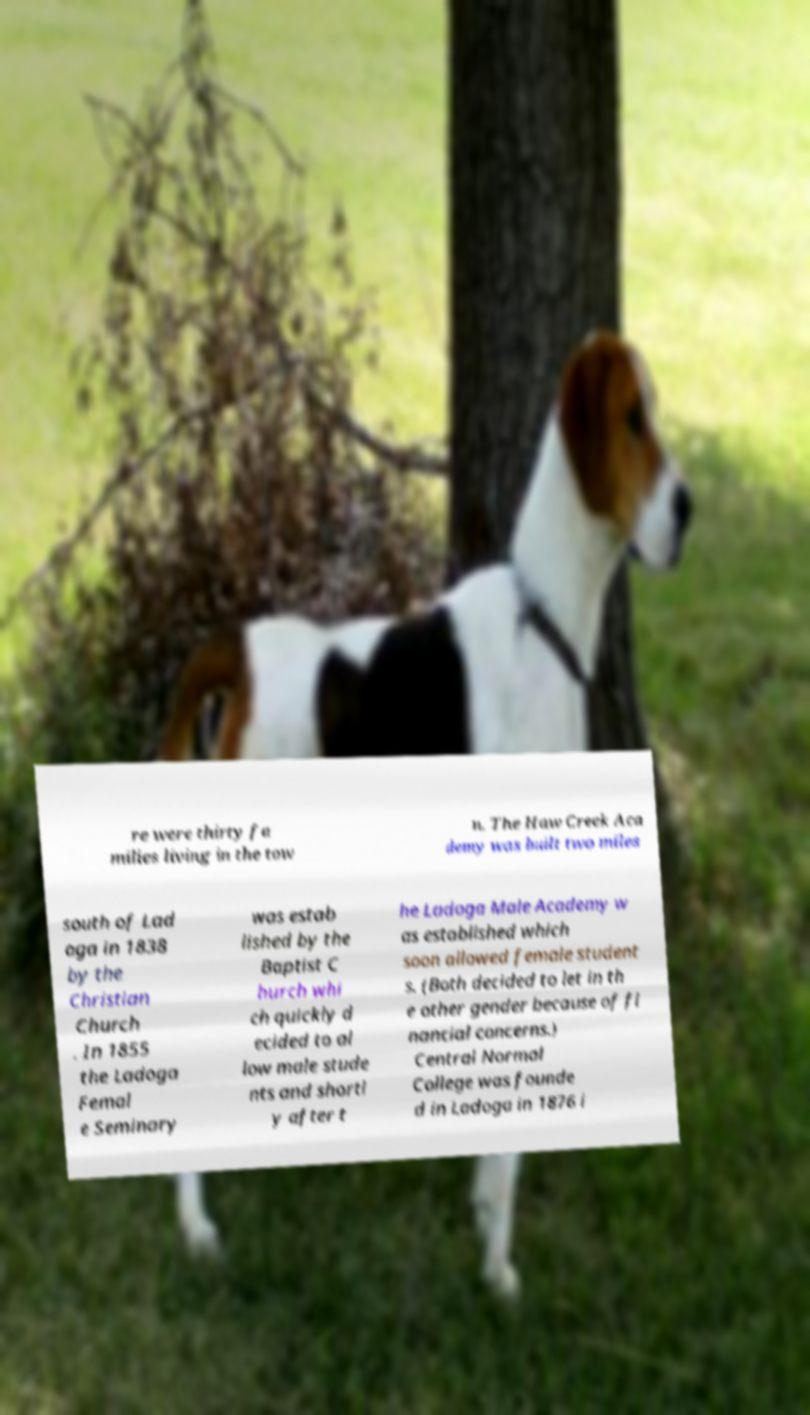There's text embedded in this image that I need extracted. Can you transcribe it verbatim? re were thirty fa milies living in the tow n. The Haw Creek Aca demy was built two miles south of Lad oga in 1838 by the Christian Church . In 1855 the Ladoga Femal e Seminary was estab lished by the Baptist C hurch whi ch quickly d ecided to al low male stude nts and shortl y after t he Ladoga Male Academy w as established which soon allowed female student s. (Both decided to let in th e other gender because of fi nancial concerns.) Central Normal College was founde d in Ladoga in 1876 i 